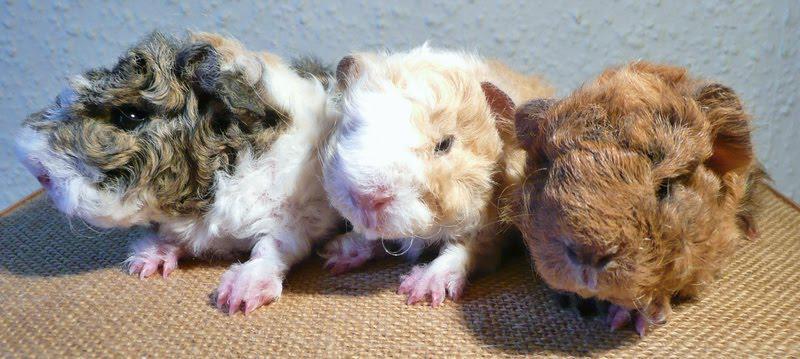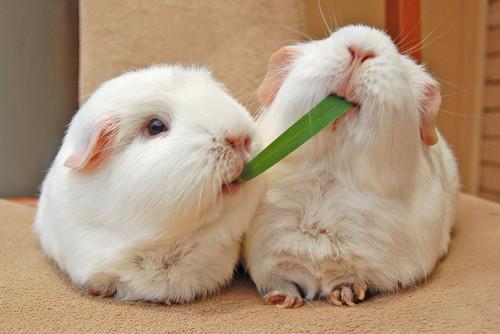The first image is the image on the left, the second image is the image on the right. Evaluate the accuracy of this statement regarding the images: "There are at least three rodents in the image on the left.". Is it true? Answer yes or no. Yes. 